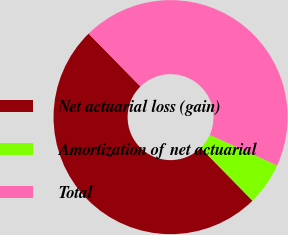<chart> <loc_0><loc_0><loc_500><loc_500><pie_chart><fcel>Net actuarial loss (gain)<fcel>Amortization of net actuarial<fcel>Total<nl><fcel>50.0%<fcel>5.88%<fcel>44.12%<nl></chart> 